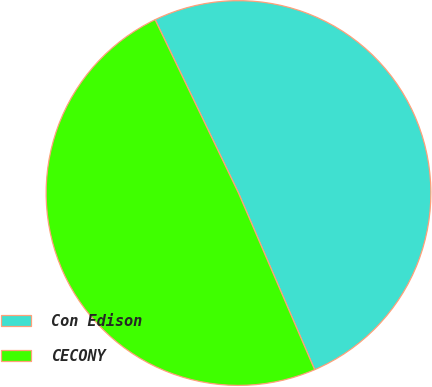<chart> <loc_0><loc_0><loc_500><loc_500><pie_chart><fcel>Con Edison<fcel>CECONY<nl><fcel>50.66%<fcel>49.34%<nl></chart> 